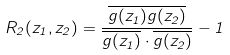Convert formula to latex. <formula><loc_0><loc_0><loc_500><loc_500>R _ { 2 } ( z _ { 1 } , z _ { 2 } ) = \frac { \overline { g ( z _ { 1 } ) g ( z _ { 2 } ) } } { \overline { g ( z _ { 1 } ) } \cdot \overline { g ( z _ { 2 } ) } } - 1</formula> 